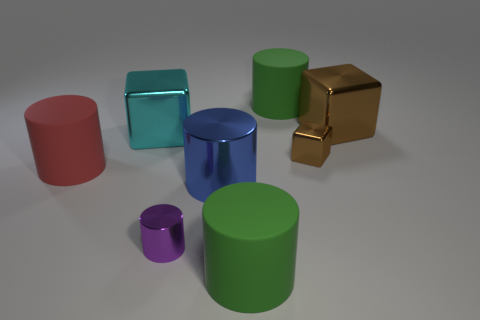Add 2 purple objects. How many objects exist? 10 Subtract all brown cubes. How many cubes are left? 1 Subtract all large blue metal cylinders. How many cylinders are left? 4 Add 6 brown metallic blocks. How many brown metallic blocks exist? 8 Subtract 0 red spheres. How many objects are left? 8 Subtract all blocks. How many objects are left? 5 Subtract 1 cubes. How many cubes are left? 2 Subtract all green cubes. Subtract all blue balls. How many cubes are left? 3 Subtract all purple balls. How many cyan blocks are left? 1 Subtract all cubes. Subtract all small spheres. How many objects are left? 5 